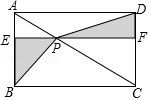Narrate what you see in the visual. The diagram features a parallelogram ABCD with a pair of diagonal lines intersecting at point P. The parallelogram is divided into four distinct regions: two triangles (△APD and △BPC) and two trapezoids (AEPF and BCFE) by a line segment EF, which is parallel to both AD and BC. The area where diagonal AC and line EF cross is shaded, highlighting the two triangles that share a common vertex at point P. This visualization could be representative of geometrical theorems or principles related to the properties of parallelograms and triangles within them. 